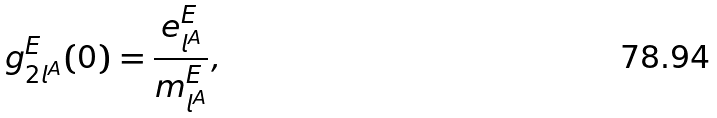<formula> <loc_0><loc_0><loc_500><loc_500>g _ { 2 l ^ { A } } ^ { E } ( 0 ) = \frac { e _ { l ^ { A } } ^ { E } } { m _ { l ^ { A } } ^ { E } } ,</formula> 